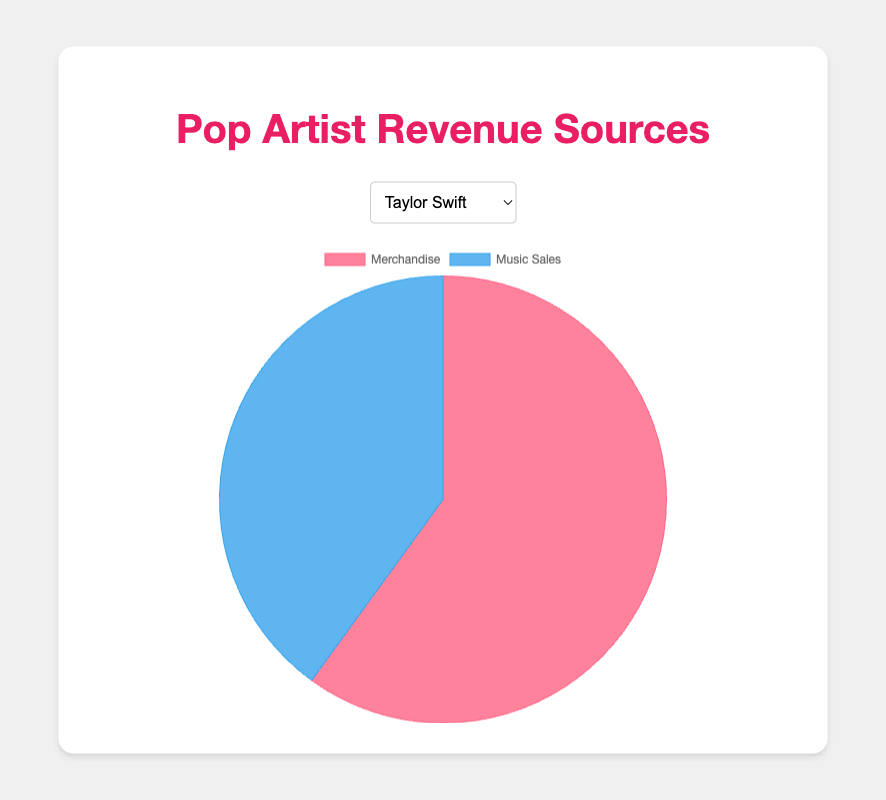What percentage of Taylor Swift's revenue comes from merchandise? The pie chart for Taylor Swift shows two sections labeled 'Merchandise' and 'Music Sales'. To find the percentage from merchandise, observe the size and the label of the 'Merchandise' section. The tooltip indicates the actual numerical values: $60,000,000 for merchandise and $40,000,000 for music sales. Calculate the total revenue, which is $60,000,000 + $40,000,000 = $100,000,000. The percentage from merchandise is ($60,000,000 / $100,000,000) * 100 = 60%.
Answer: 60% Which artist has the highest revenue from music sales? Look at the pie charts for each artist and identify the segment size for 'Music Sales'. The tooltip provides the actual values. Comparing the values for music sales: Taylor Swift ($40,000,000), Drake ($50,000,000), Beyoncé ($45,000,000), Ed Sheeran ($35,000,000), and Ariana Grande ($40,000,000). The highest value is $50,000,000 for Drake.
Answer: Drake For Beyoncé, how much more revenue is generated from merchandise compared to music sales? In Beyoncé's pie chart, observe the sections labeled 'Merchandise' and 'Music Sales'. The tooltip displays the actual values. The revenue from merchandise is $80,000,000 and from music sales is $45,000,000. The difference is $80,000,000 - $45,000,000 = $35,000,000.
Answer: $35,000,000 Among the artists, who has the smallest proportion of revenue from merchandise? For each artist, find the sections of the pie chart representing 'Merchandise' and compare their proportions. To determine the proportion, check the tooltip values. Calculate the percentage for each: Taylor Swift (60%), Drake (58.33%), Beyoncé (64%), Ed Sheeran (61.11%), Ariana Grande (55.56%). The smallest proportion is for Ariana Grande at 55.56%.
Answer: Ariana Grande What is the total revenue generated by Ed Sheeran from both merchandise and music sales? Look at Ed Sheeran’s pie chart and sum the values from both sections. The tooltip indicates $55,000,000 from merchandise and $35,000,000 from music sales. The total revenue is $55,000,000 + $35,000,000 = $90,000,000.
Answer: $90,000,000 If all five artists combine their merchandise revenue, what will be the total? Sum the merchandise revenues from the tooltips for each artist: Taylor Swift ($60,000,000), Drake ($70,000,000), Beyoncé ($80,000,000), Ed Sheeran ($55,000,000), Ariana Grande ($50,000,000). The total is $60,000,000 + $70,000,000 + $80,000,000 + $55,000,000 + $50,000,000 = $315,000,000.
Answer: $315,000,000 Is the revenue from merchandise for any artist equal to the revenue from music sales for any other artist? Compare the values from the tooltips for each artist's 'Merchandise' and 'Music Sales' sections. Check if any merchandise value matches any music sales value: Taylor Swift ($60,000,000, $40,000,000), Drake ($70,000,000, $50,000,000), Beyoncé ($80,000,000, $45,000,000), Ed Sheeran ($55,000,000, $35,000,000), Ariana Grande ($50,000,000, $40,000,000). None of the merchandise values match the music sales values exactly.
Answer: No Which artist has the largest difference between their merchandise and music sales revenues? Calculate the difference between merchandise and music sales for each artist from their pie chart values. Differences are: Taylor Swift ($60,000,000 - $40,000,000 = $20,000,000), Drake ($70,000,000 - $50,000,000 = $20,000,000), Beyoncé ($80,000,000 - $45,000,000 = $35,000,000), Ed Sheeran ($55,000,000 - $35,000,000 = $20,000,000), Ariana Grande ($50,000,000 - $40,000,000 = $10,000,000). The largest difference is for Beyoncé with $35,000,000.
Answer: Beyoncé 